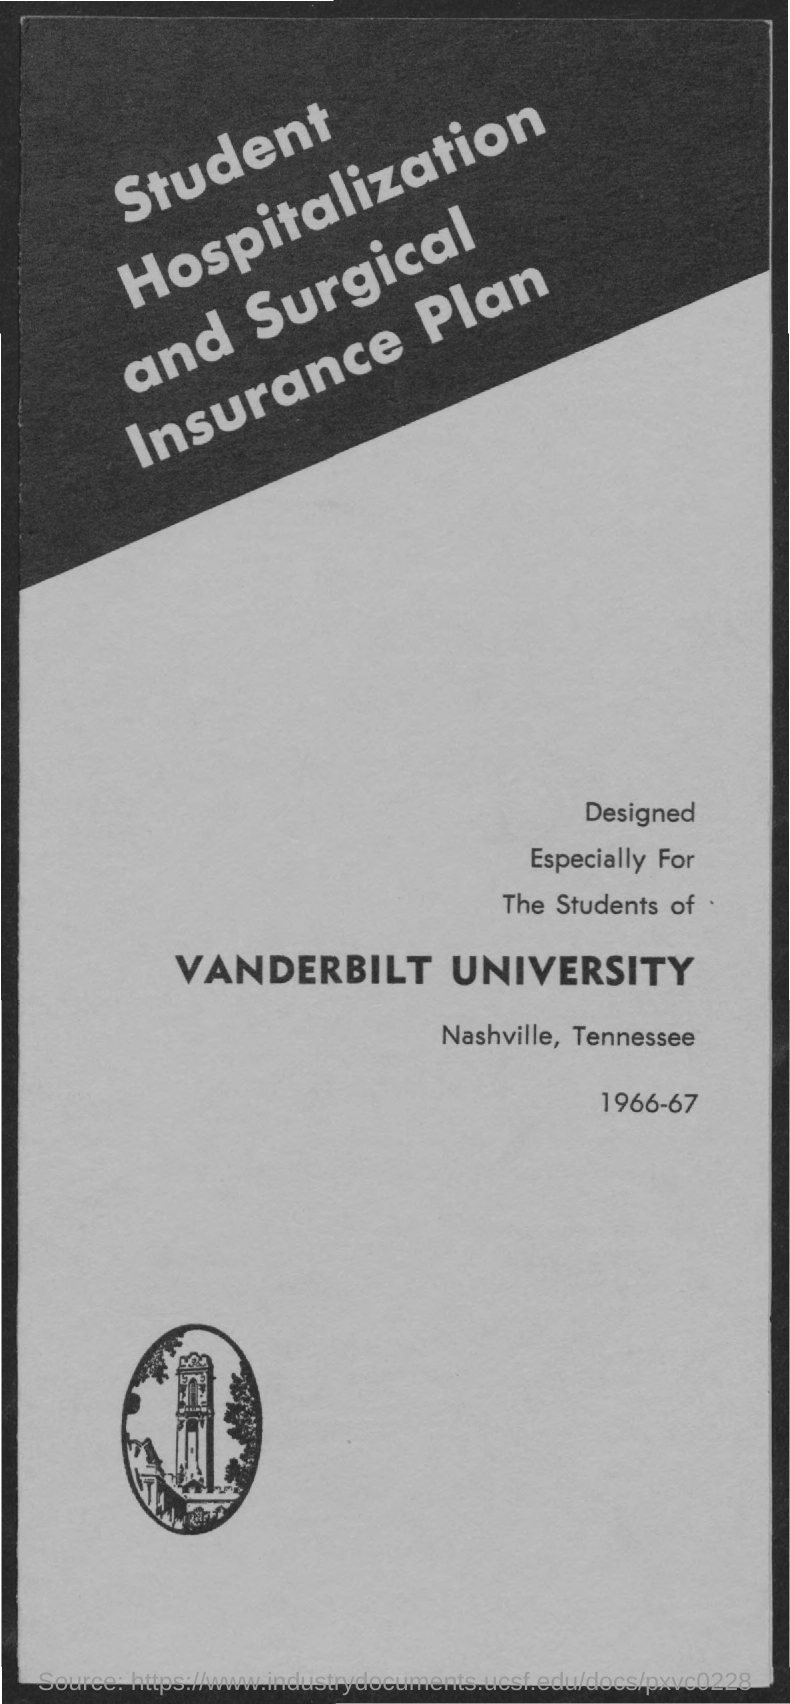What is the name of the university?
Provide a succinct answer. Vanderbilt University. What is the name of the Insurance Plan?
Provide a succinct answer. Student Hospitalization and Surgical Insurance Plan. What is the year mentioned at the bottom?
Keep it short and to the point. 1966-67. 